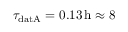<formula> <loc_0><loc_0><loc_500><loc_500>\tau _ { d a t A } = 0 . 1 3 \, h \approx 8</formula> 